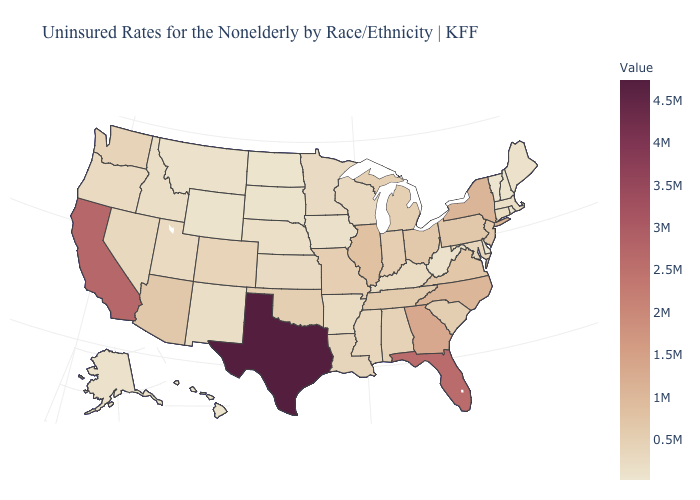Which states have the lowest value in the South?
Answer briefly. Delaware. Does Texas have the highest value in the USA?
Give a very brief answer. Yes. Among the states that border Georgia , which have the highest value?
Short answer required. Florida. Does Tennessee have the highest value in the South?
Quick response, please. No. Does the map have missing data?
Quick response, please. No. Which states have the highest value in the USA?
Keep it brief. Texas. Which states have the highest value in the USA?
Concise answer only. Texas. Does Missouri have the highest value in the MidWest?
Quick response, please. No. 